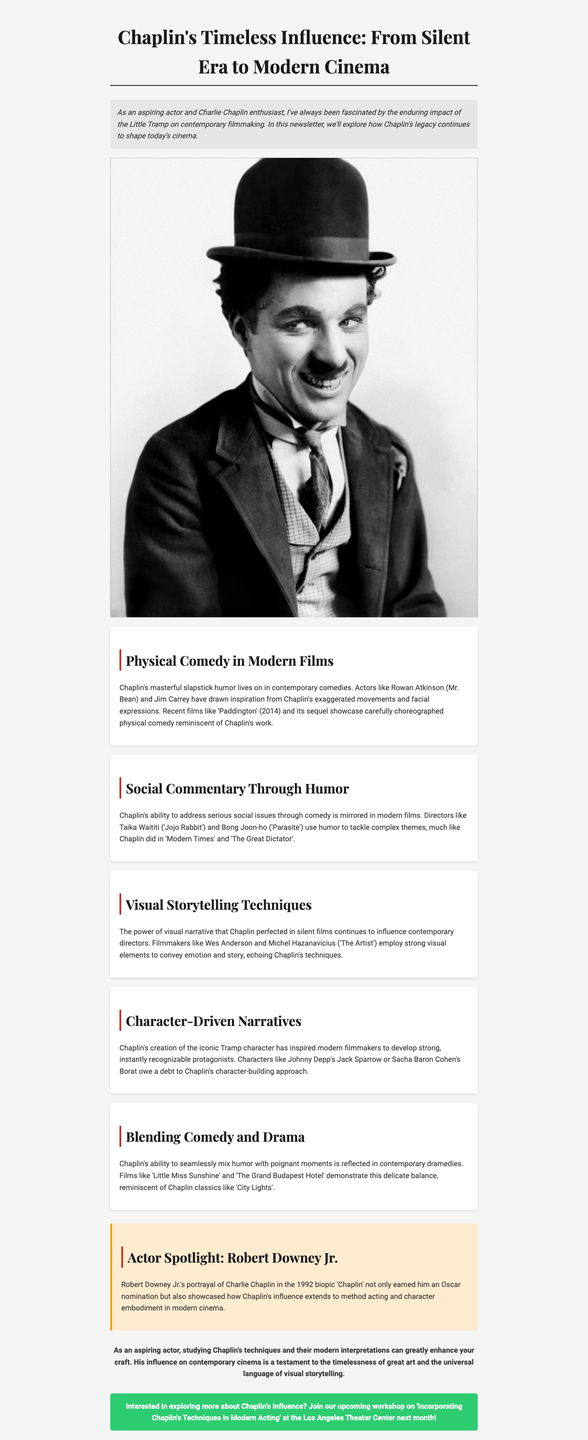What is the title of the newsletter? The title of the newsletter is explicitly stated at the beginning of the document.
Answer: Chaplin's Timeless Influence: From Silent Era to Modern Cinema Who portrayed Charlie Chaplin in the 1992 biopic? The document explicitly mentions the actor who portrayed Chaplin.
Answer: Robert Downey Jr Which film released in 2014 showcases physical comedy reminiscent of Chaplin? The document lists specific films that illustrate Chaplin's influence in modern cinema.
Answer: Paddington What type of comedy is discussed in relation to modern films? The document categorizes a specific type of comedy that relates to Chaplin's influence.
Answer: Physical Comedy Name a director mentioned who uses humor to address serious social issues. The document cites directors who reflect Chaplin's approach to social commentary.
Answer: Taika Waititi What aspect of storytelling did Chaplin perfect that continues to influence filmmakers today? The document discusses a specific technique that remains significant in visual narratives.
Answer: Visual Storytelling Techniques Which section discusses characters inspired by Chaplin's character-building approach? The document divides its content into different sections, each covering unique themes.
Answer: Character-Driven Narratives What is the call to action in the newsletter? The document provides a specific invitation to engage with further learning opportunities.
Answer: Incorporating Chaplin's Techniques in Modern Acting Which film is mentioned as an example of blending comedy and drama? The document provides examples of films that reflect specific thematic elements connected to Chaplin's legacy.
Answer: Little Miss Sunshine 